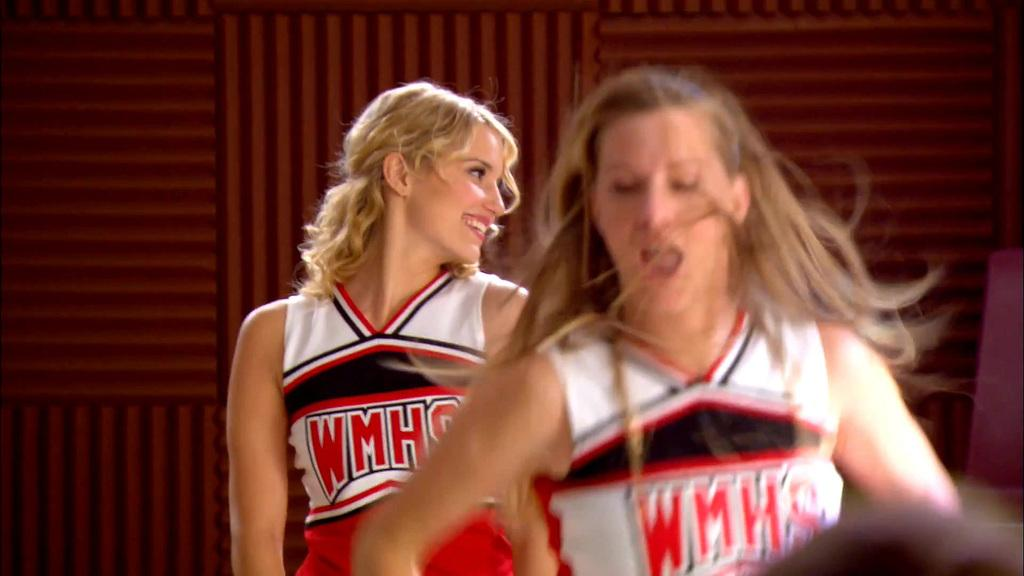<image>
Share a concise interpretation of the image provided. Two cheerleaders with WMHS written on their cheerleading costumes 